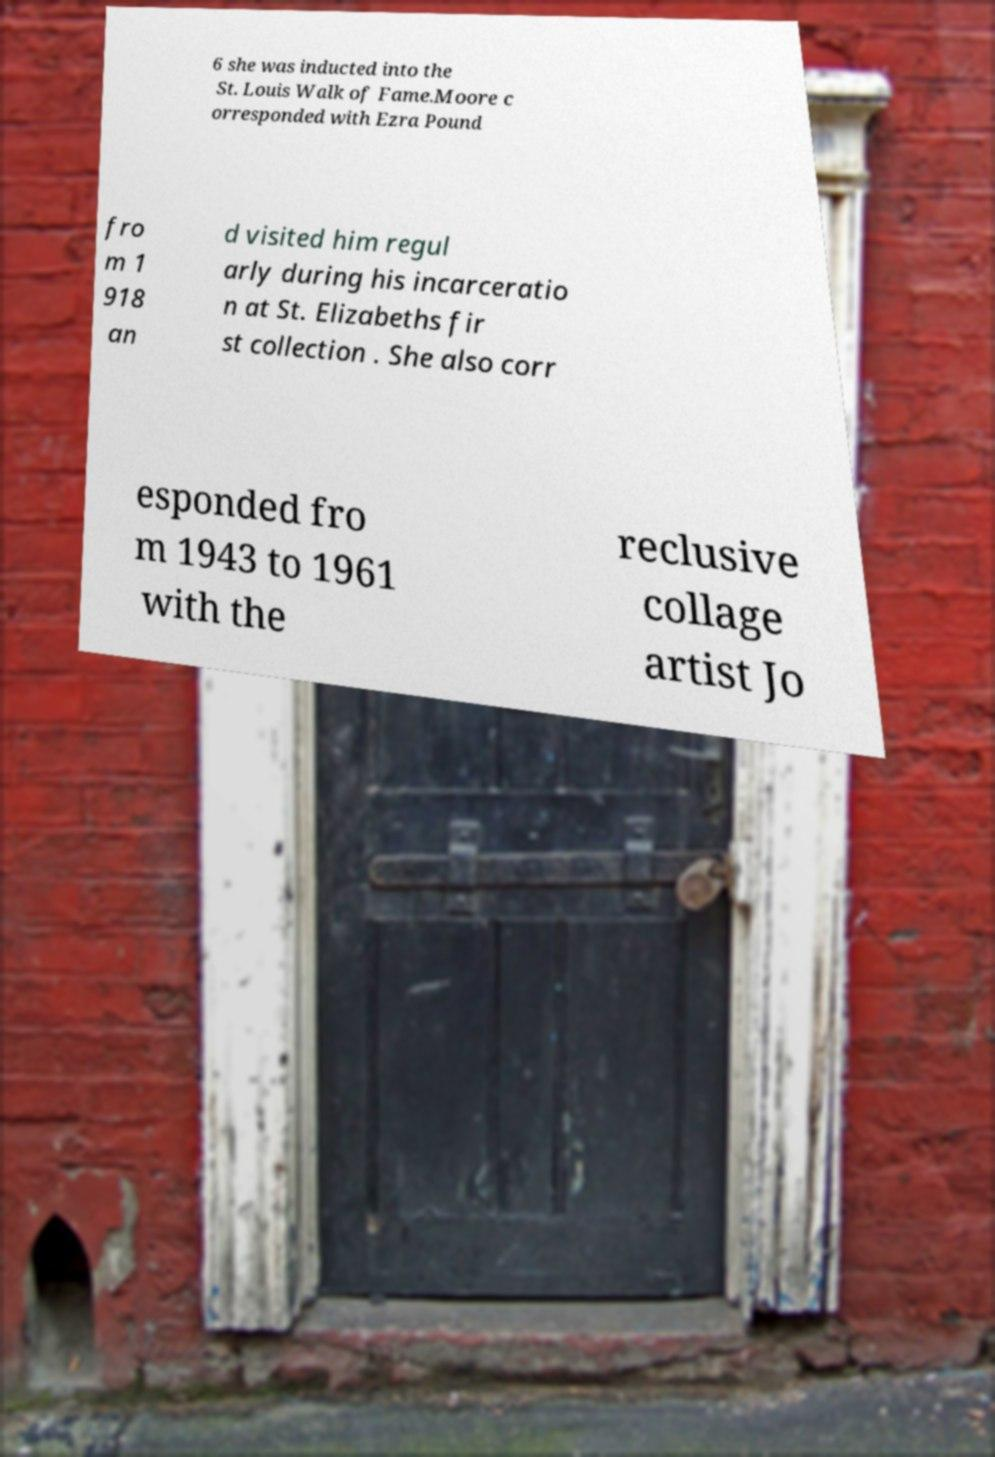Can you accurately transcribe the text from the provided image for me? 6 she was inducted into the St. Louis Walk of Fame.Moore c orresponded with Ezra Pound fro m 1 918 an d visited him regul arly during his incarceratio n at St. Elizabeths fir st collection . She also corr esponded fro m 1943 to 1961 with the reclusive collage artist Jo 